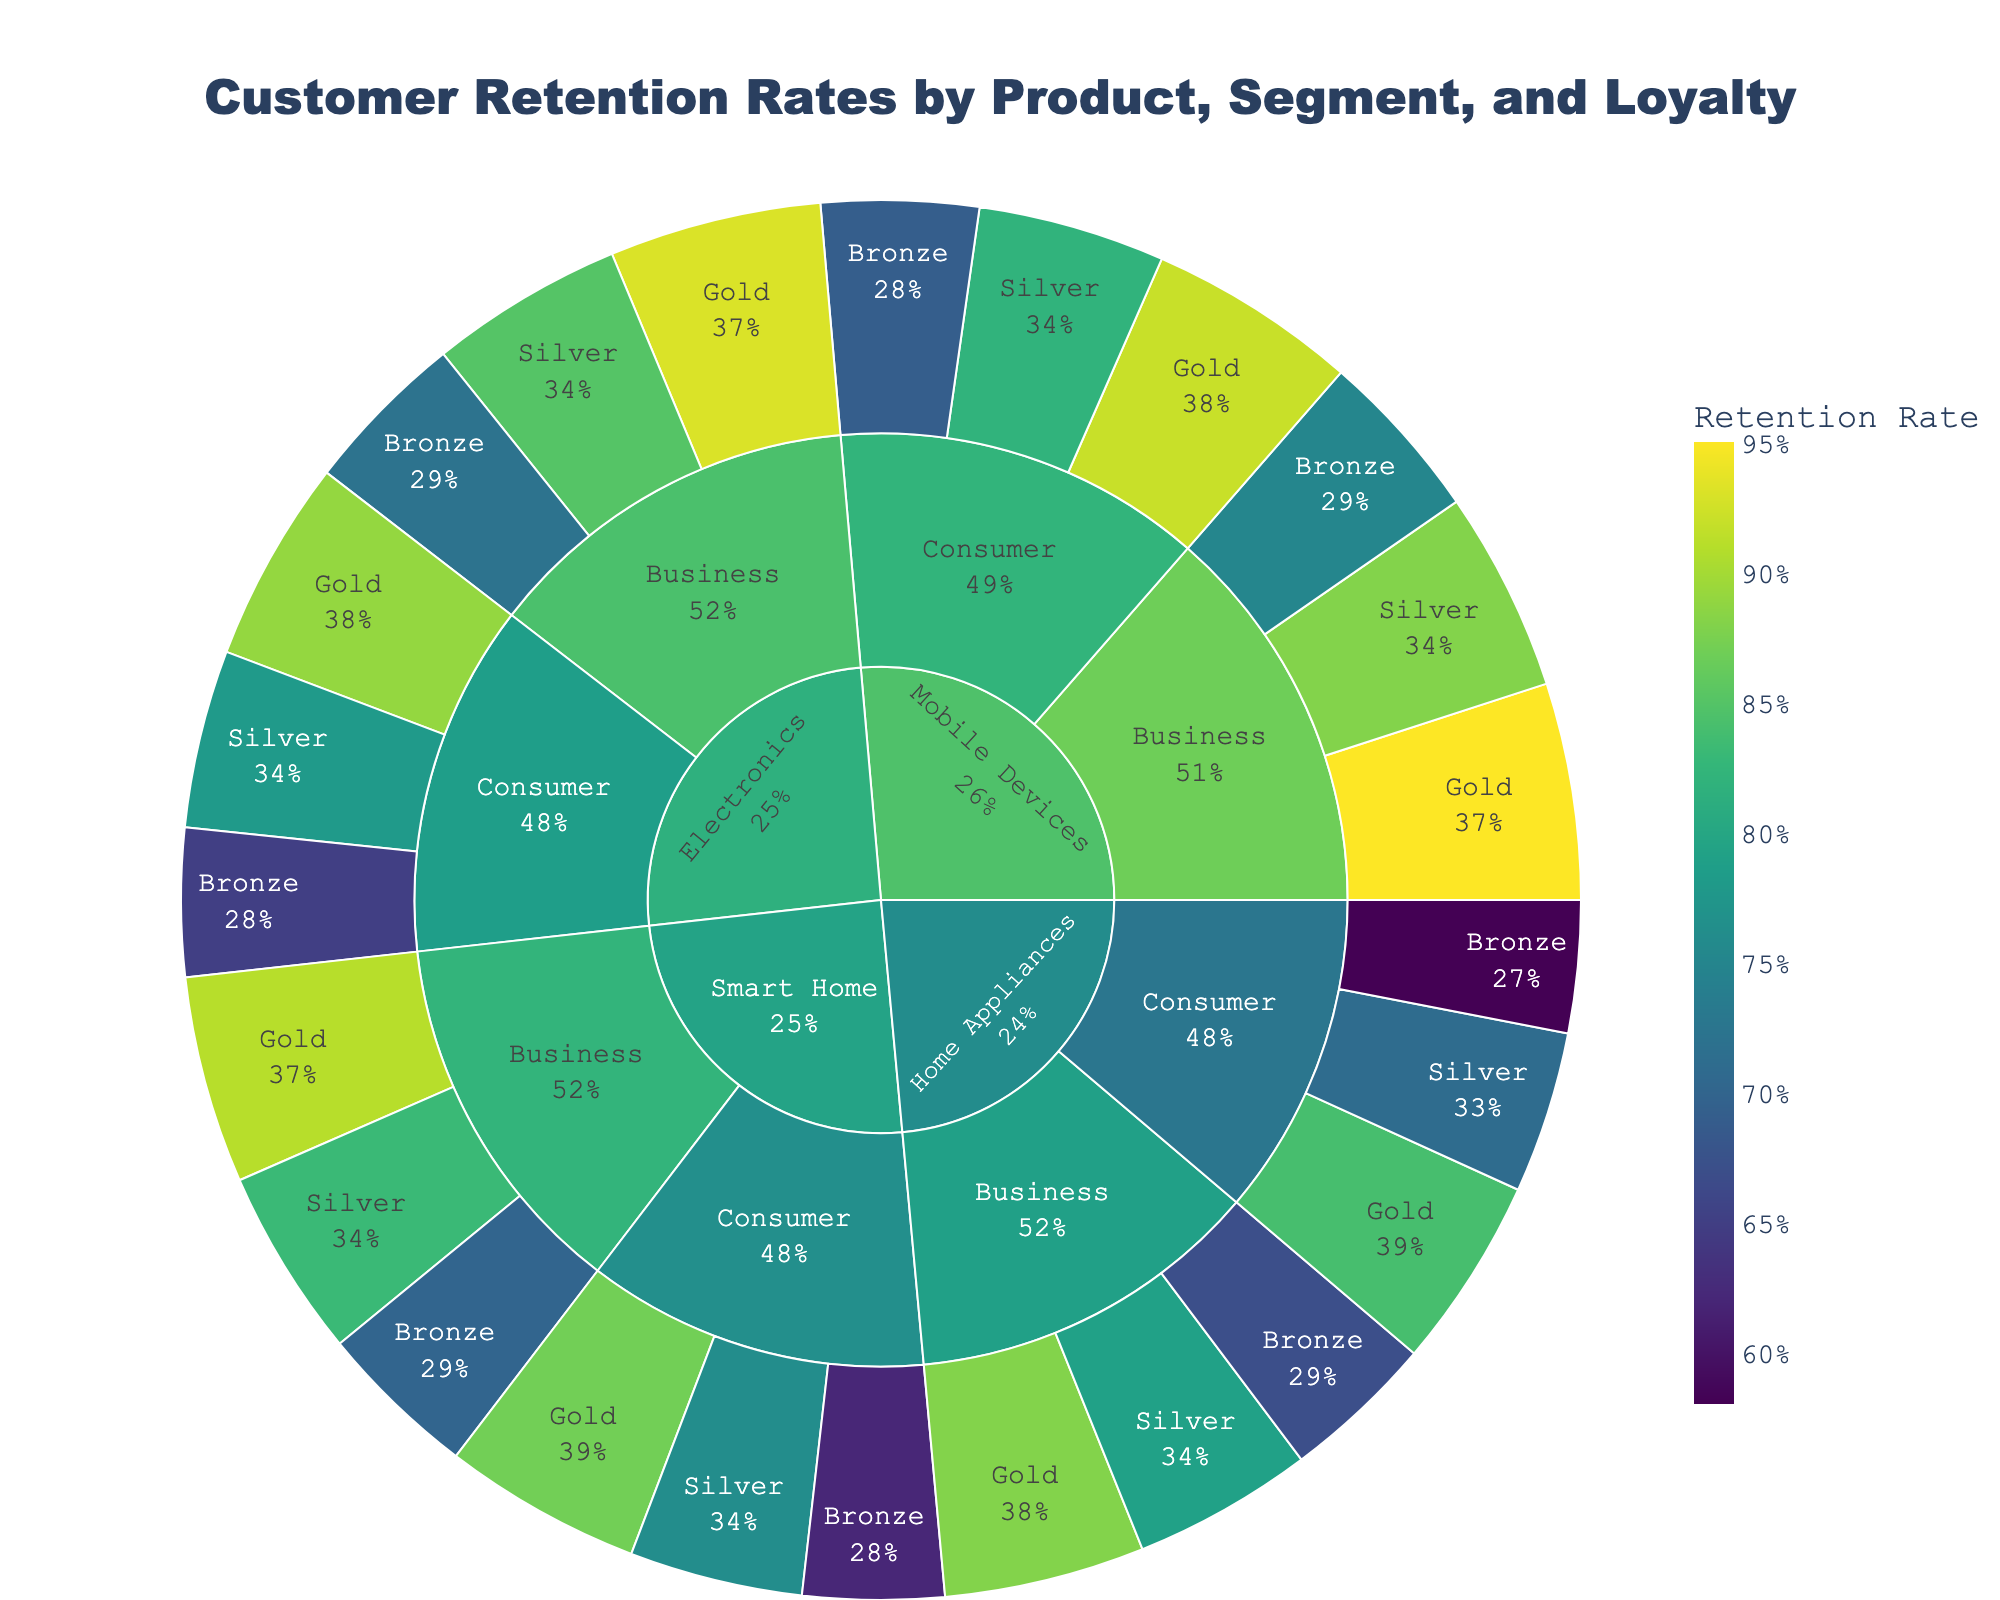What is the title of the plot? The title of the plot is displayed prominently at the top. It reads "Customer Retention Rates by Product, Segment, and Loyalty".
Answer: Customer Retention Rates by Product, Segment, and Loyalty Which loyalty tier has the highest retention rate within the Mobile Devices product line? By examining the sectored arrangement of the plot, the Mobile Devices segment shows that the Gold tier has the highest retention rate.
Answer: Gold What is the retention rate for Business customers in the Silver loyalty tier within the Smart Home product line? By navigating through the layers, starting from Smart Home, then Business, and finally Silver, the retention rate displayed for Business customers in the Silver tier is shown to be 83%.
Answer: 83% How do the retention rates of Business customers in the Gold tier compare between Electronics and Home Appliances? The comparison involves examining both segments. Electronics shows a retention rate of 93% for the Business Gold tier, while Home Appliances shows a rate of 88%. Hence, Electronics has a higher retention rate for Business customers in the Gold tier.
Answer: Electronics: 93%, Home Appliances: 88% What is the average retention rate for Consumer customers in the Silver tier across all product lines? First, find the retention rates for Consumer customers in the Silver tier across all products:
Electronics: 78%, Home Appliances: 71%, Smart Home: 76%, Mobile Devices: 82%.
Then, calculate the average: (78% + 71% + 76% + 82%) / 4 = 76.75%.
Answer: 76.75% Which product line has the lowest retention rate for Consumer customers in the Bronze tier? By checking the retention rates for Consumer-Bronze in each product line:
Electronics: 65%, Home Appliances: 58%, Smart Home: 62%, Mobile Devices: 69%.
Home Appliances has the lowest rate at 58%.
Answer: Home Appliances Is the retention rate for Consumer customers in the Gold tier higher in Mobile Devices or Smart Home? Examine the retention rates for Consumer-Gold in both product lines:
Mobile Devices: 92%, Smart Home: 87%.
Mobile Devices has a higher retention rate.
Answer: Mobile Devices What is the difference in retention rates between Business customers in the Gold and Bronze tiers within the Home Appliances line? For Home Appliances, the retention rates are:
Gold: 88%, Bronze: 67%.
The difference is 88% - 67% = 21%.
Answer: 21% How many loyalty tiers are represented in the Electronics product line? By looking at the Electronics segment, it is divided into three loyalty tiers: Bronze, Silver, and Gold.
Answer: Three What is the total retention rate for all customer segments in the Business category across all product lines? Combine retention rates of Business customers from all product lines:
Electronics: 72% + 85% + 93%
Home Appliances: 67% + 79% + 88%
Smart Home: 70% + 83% + 91%
Mobile Devices: 75% + 88% + 95%
Summing these percentages: (72 + 85 + 93) + (67 + 79 + 88) + (70 + 83 + 91) + (75 + 88 + 95) = 986%.
Answer: 986% 